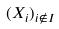Convert formula to latex. <formula><loc_0><loc_0><loc_500><loc_500>( X _ { i } ) _ { i \notin I }</formula> 